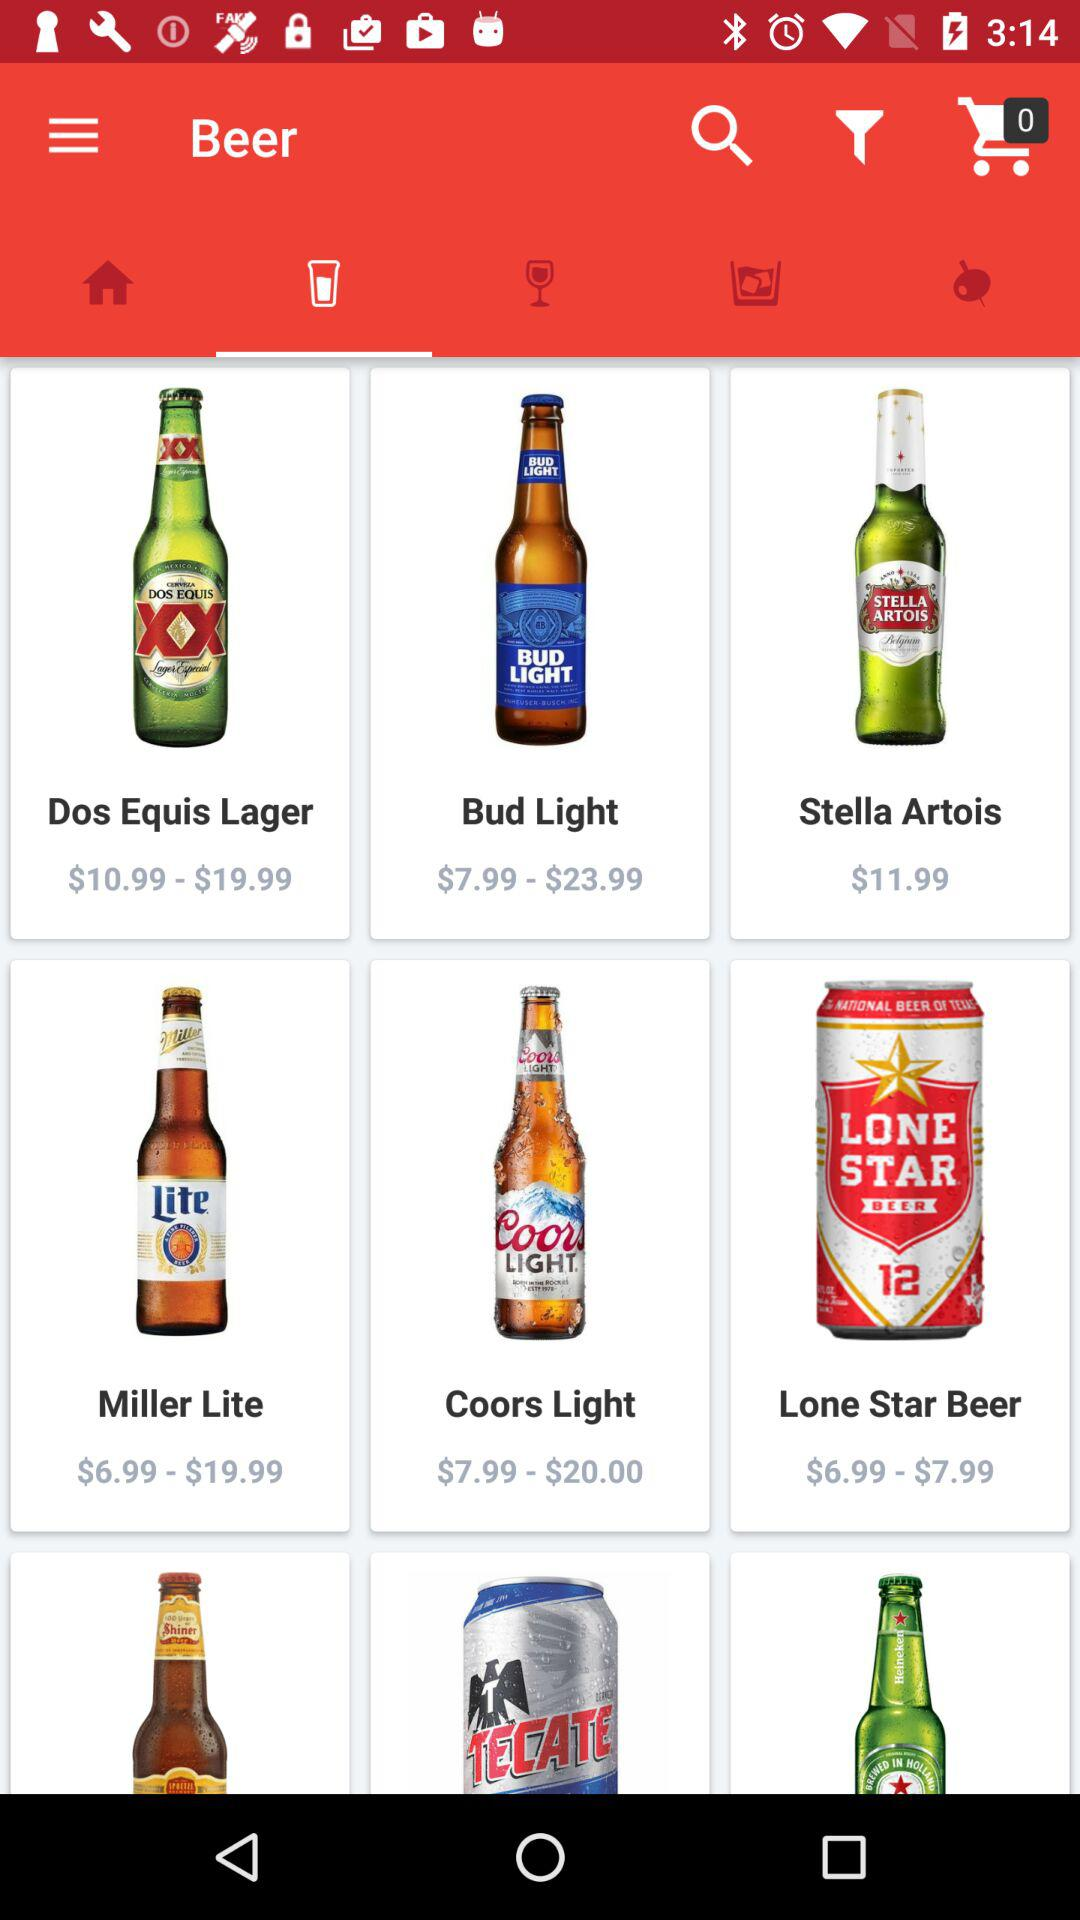What is the price of "Coors Light" beer? The price of "Coors Light" beer ranges from $7.99 to $20. 